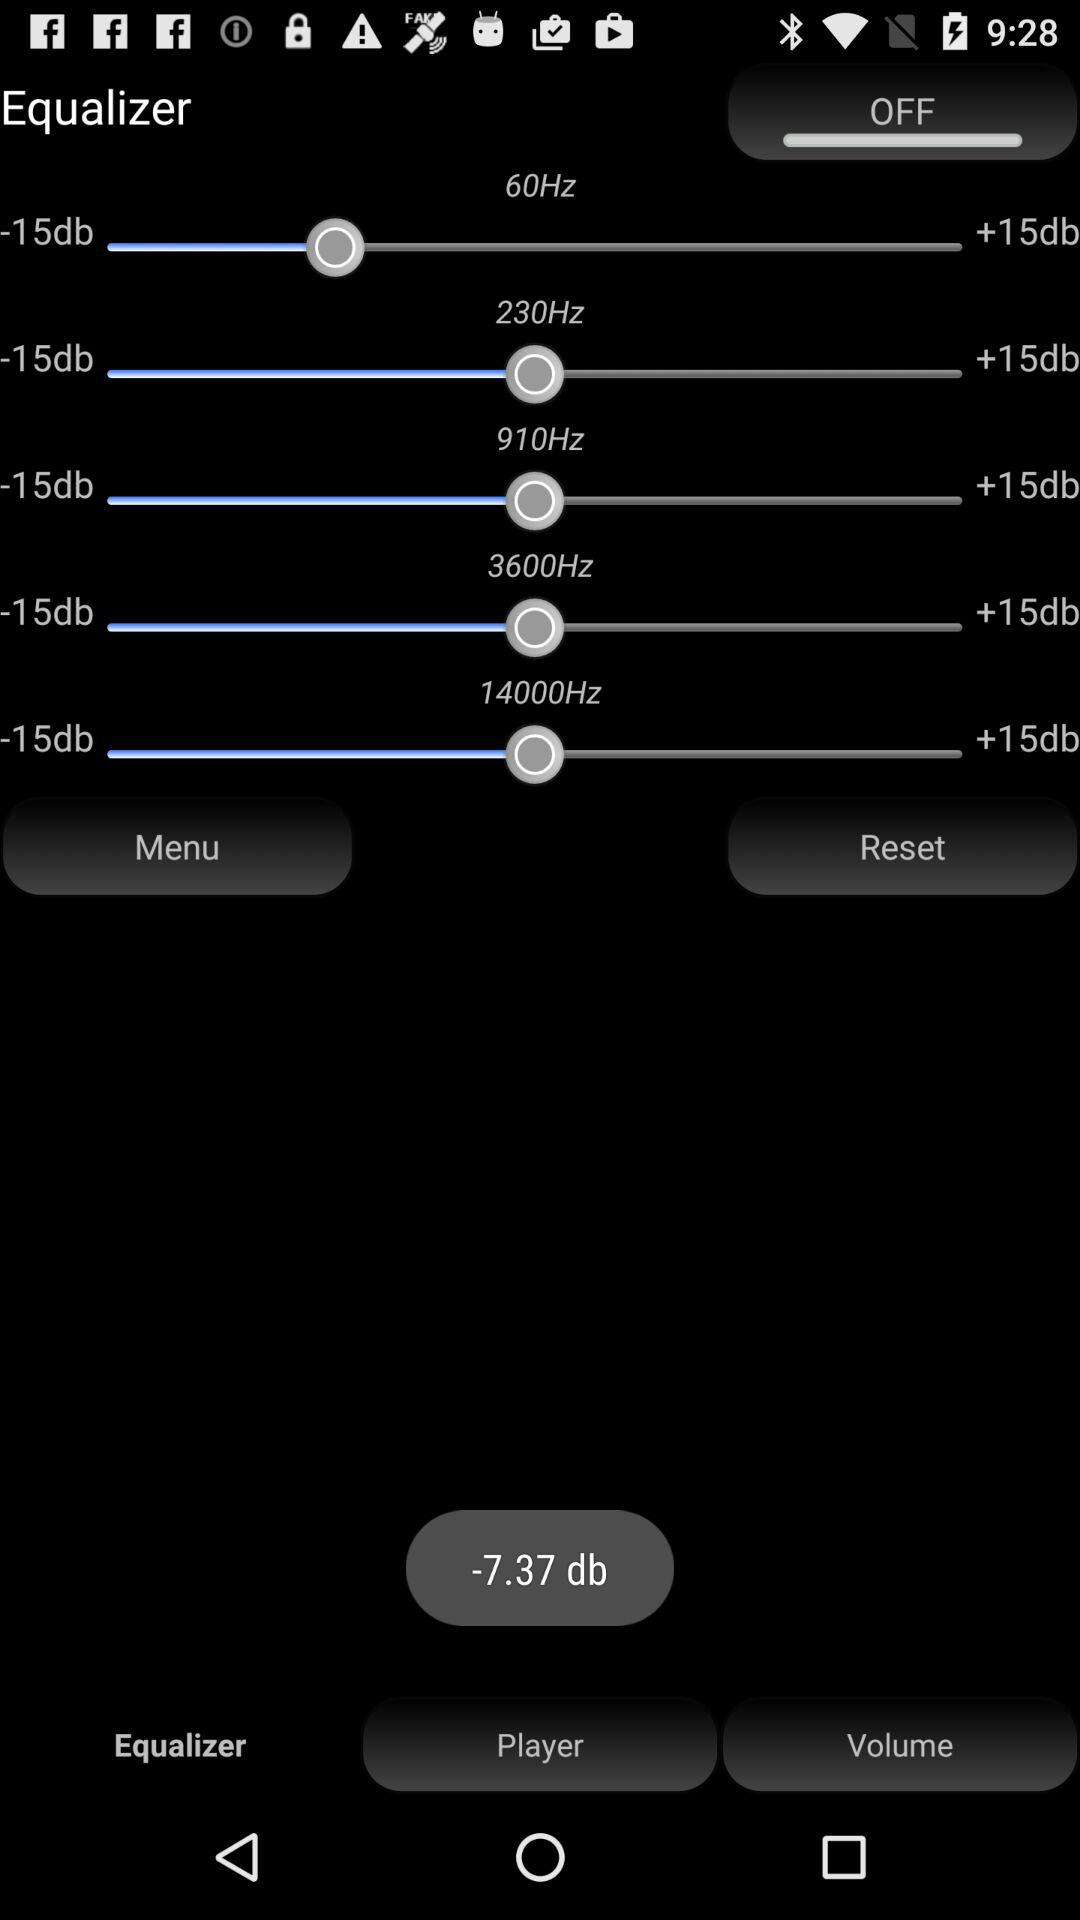What is the maximum frequency of the equalizer? The maximum frequency of the equalizer is 14000Hz. 